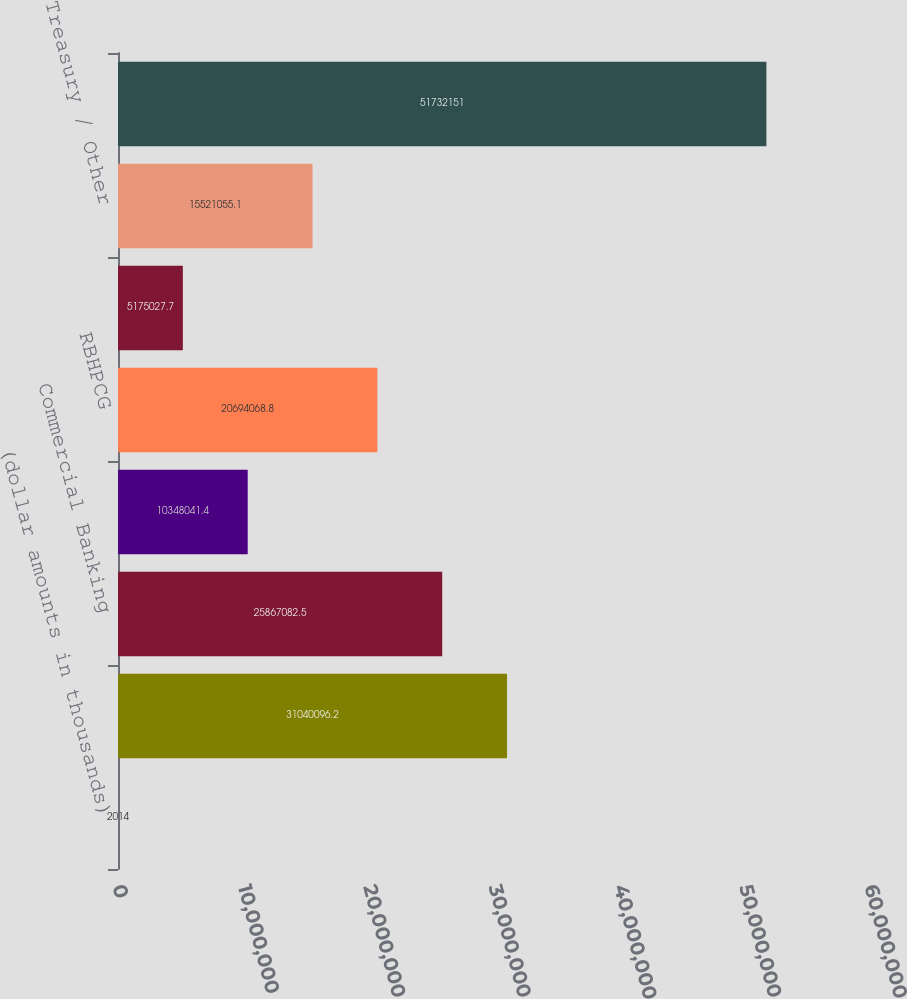Convert chart. <chart><loc_0><loc_0><loc_500><loc_500><bar_chart><fcel>(dollar amounts in thousands)<fcel>Retail & Business Banking<fcel>Commercial Banking<fcel>AFCRE<fcel>RBHPCG<fcel>Home Lending<fcel>Treasury / Other<fcel>Total<nl><fcel>2014<fcel>3.10401e+07<fcel>2.58671e+07<fcel>1.0348e+07<fcel>2.06941e+07<fcel>5.17503e+06<fcel>1.55211e+07<fcel>5.17322e+07<nl></chart> 